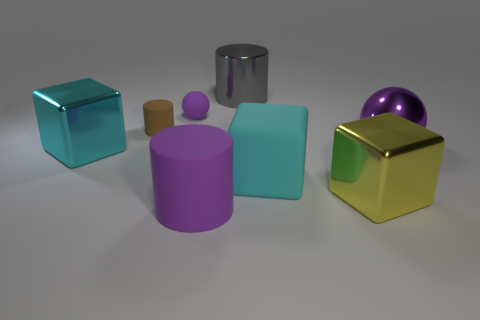Add 2 brown matte objects. How many objects exist? 10 Subtract all cylinders. How many objects are left? 5 Subtract 0 blue cylinders. How many objects are left? 8 Subtract all gray shiny cylinders. Subtract all large metallic objects. How many objects are left? 3 Add 3 large purple shiny things. How many large purple shiny things are left? 4 Add 4 rubber cubes. How many rubber cubes exist? 5 